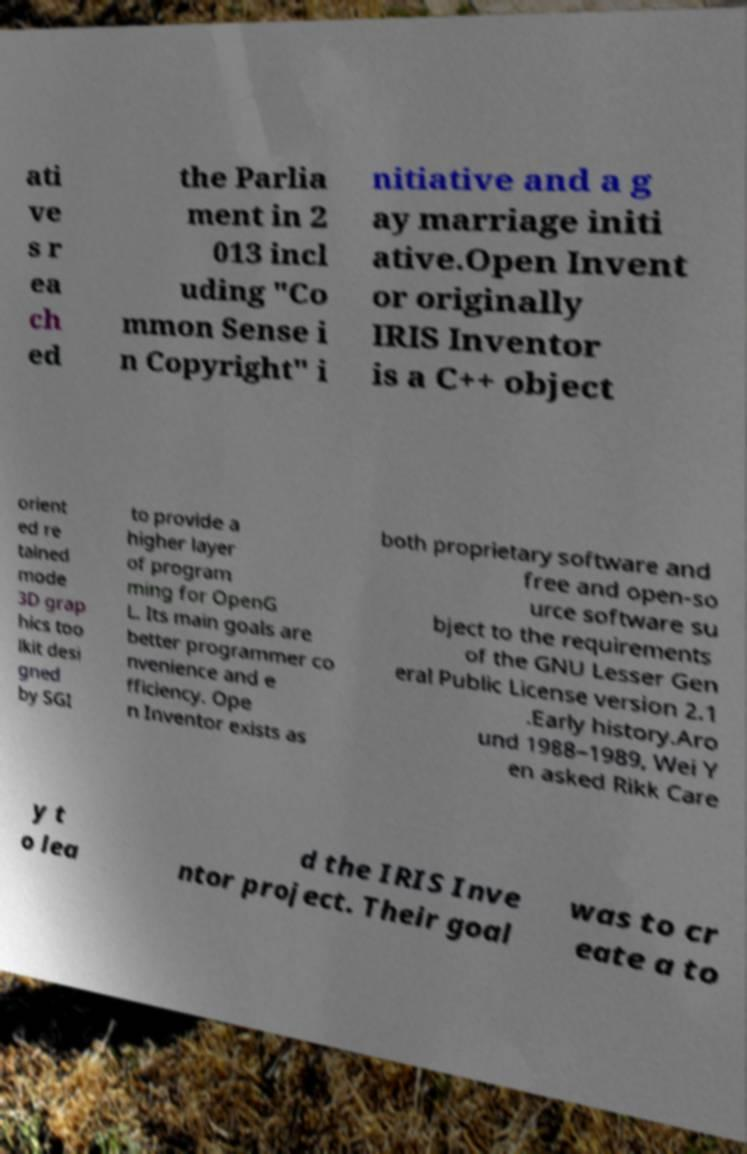What messages or text are displayed in this image? I need them in a readable, typed format. ati ve s r ea ch ed the Parlia ment in 2 013 incl uding "Co mmon Sense i n Copyright" i nitiative and a g ay marriage initi ative.Open Invent or originally IRIS Inventor is a C++ object orient ed re tained mode 3D grap hics too lkit desi gned by SGI to provide a higher layer of program ming for OpenG L. Its main goals are better programmer co nvenience and e fficiency. Ope n Inventor exists as both proprietary software and free and open-so urce software su bject to the requirements of the GNU Lesser Gen eral Public License version 2.1 .Early history.Aro und 1988–1989, Wei Y en asked Rikk Care y t o lea d the IRIS Inve ntor project. Their goal was to cr eate a to 